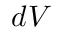Convert formula to latex. <formula><loc_0><loc_0><loc_500><loc_500>d V</formula> 